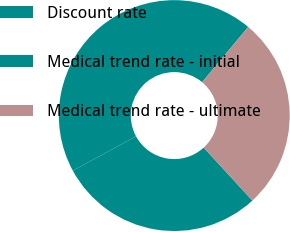<chart> <loc_0><loc_0><loc_500><loc_500><pie_chart><fcel>Discount rate<fcel>Medical trend rate - initial<fcel>Medical trend rate - ultimate<nl><fcel>28.92%<fcel>43.98%<fcel>27.11%<nl></chart> 